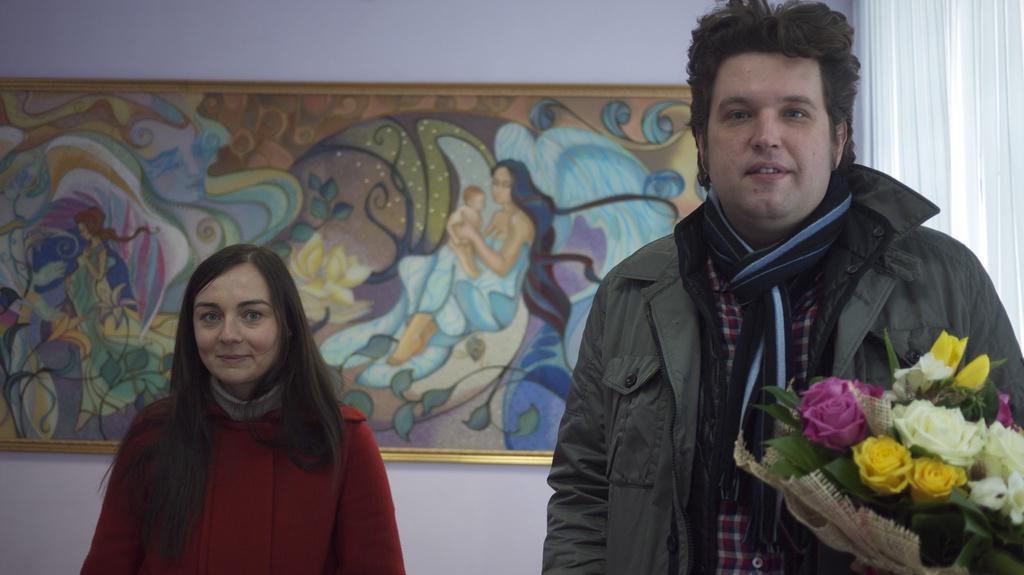In one or two sentences, can you explain what this image depicts? In this image we can see two persons. There is a bouquet, a photo frame on the wall and a curtain in the image. 